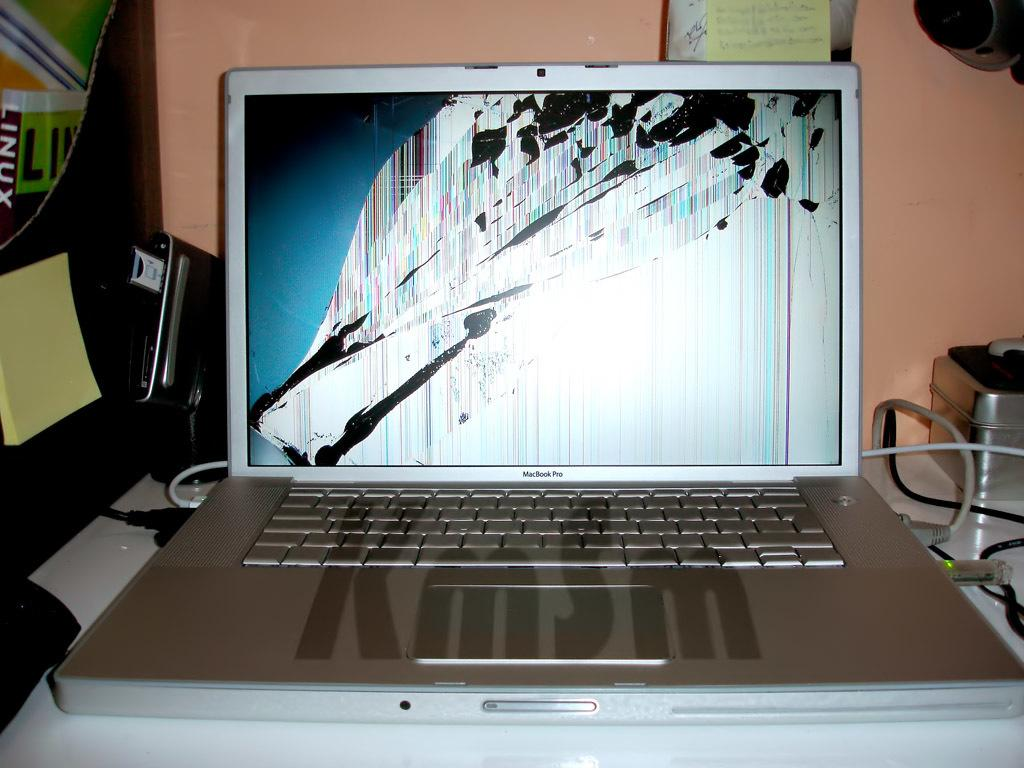Provide a one-sentence caption for the provided image. A picture of a laptop with a damaged screen and a watermark that says "KmSm.". 